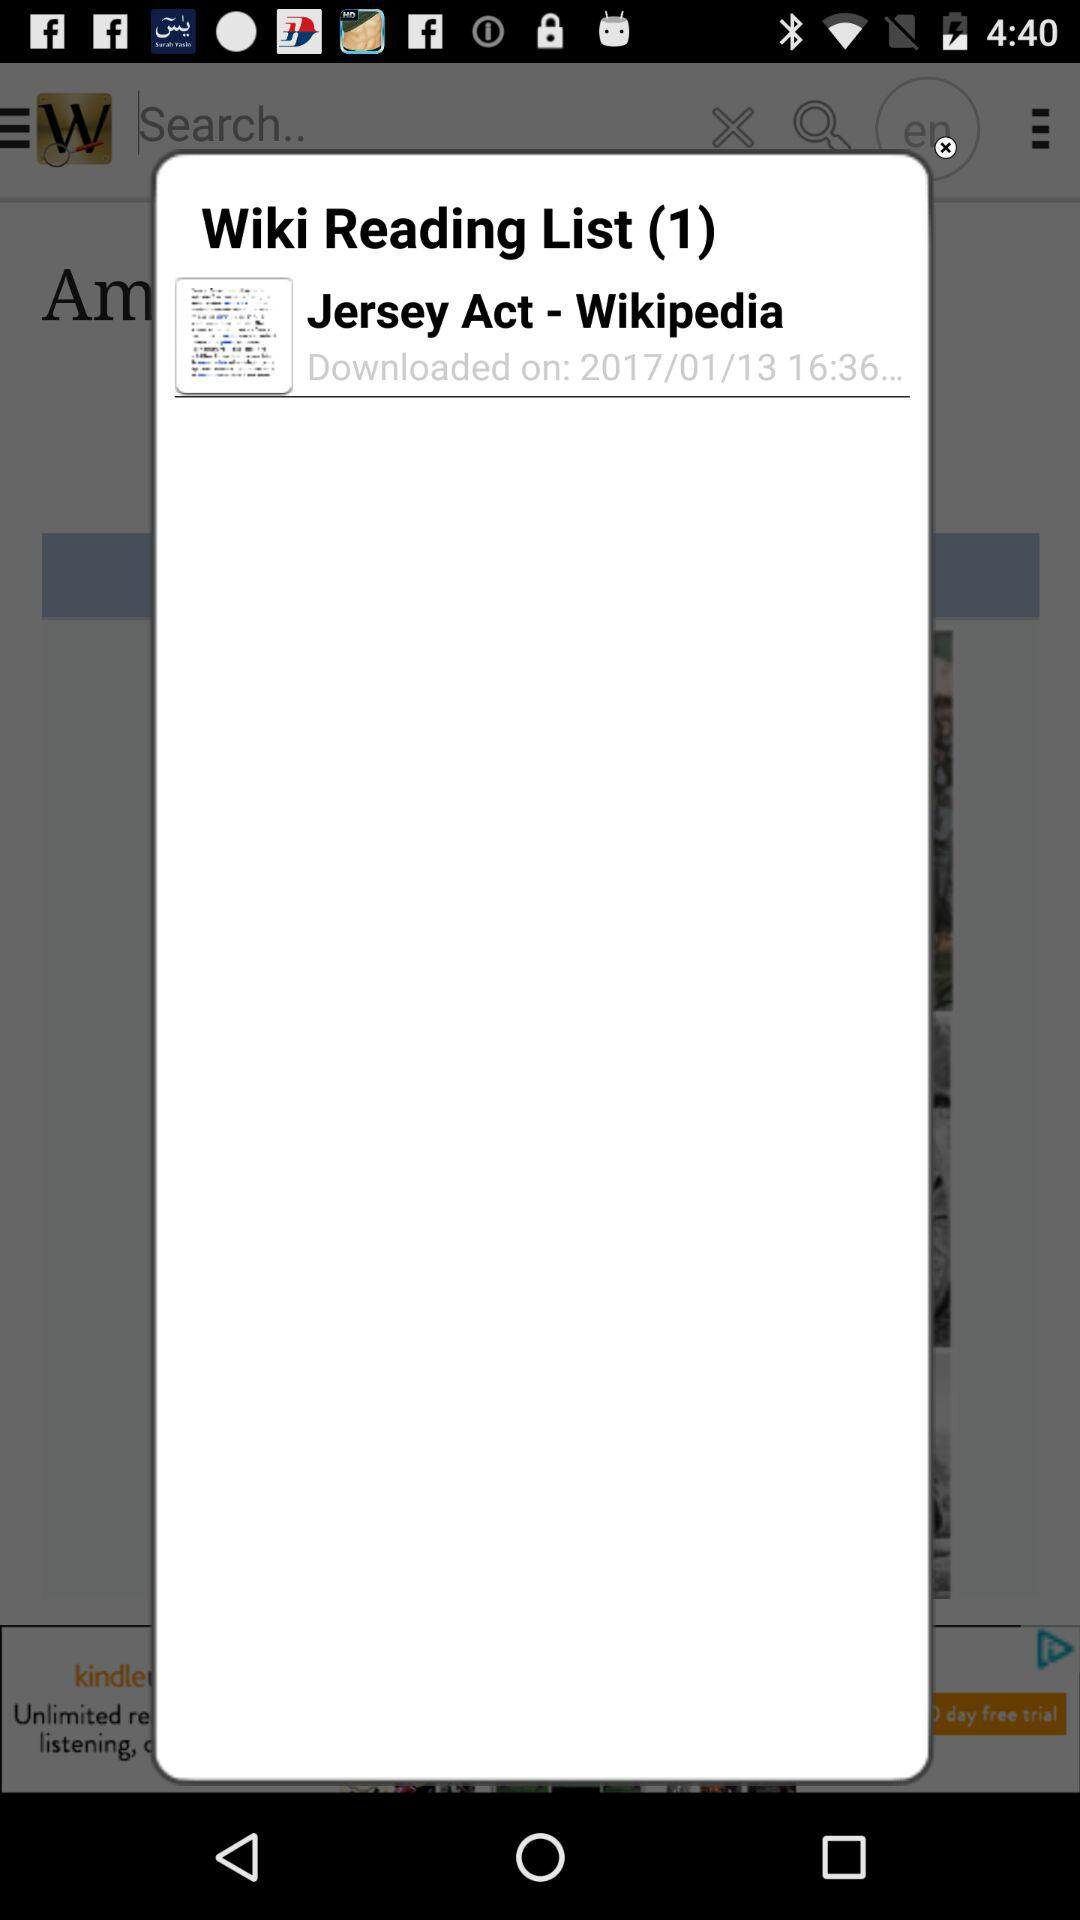What is the download date? The download date is January 1, 2013. 